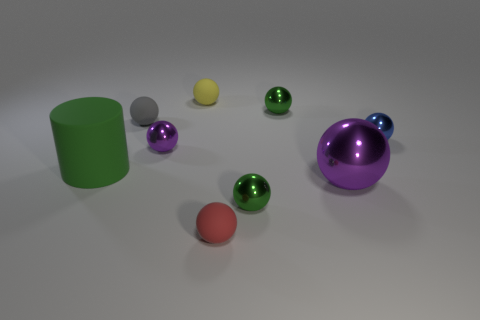Is there anything else that is the same color as the large metal thing?
Provide a short and direct response. Yes. There is a green object behind the big cylinder; what is it made of?
Offer a very short reply. Metal. Do the red sphere and the green rubber thing have the same size?
Make the answer very short. No. What number of other things are there of the same size as the gray rubber sphere?
Your response must be concise. 6. There is a rubber object in front of the metallic object in front of the purple object in front of the green matte object; what shape is it?
Your response must be concise. Sphere. How many things are either red objects to the right of the gray object or green metal objects in front of the rubber cylinder?
Provide a short and direct response. 2. What size is the purple ball to the left of the rubber sphere in front of the large purple metal object?
Make the answer very short. Small. Do the tiny metallic object in front of the cylinder and the large cylinder have the same color?
Your answer should be compact. Yes. Is there a small purple metallic thing that has the same shape as the red rubber object?
Your response must be concise. Yes. What is the color of the ball that is the same size as the green cylinder?
Ensure brevity in your answer.  Purple. 